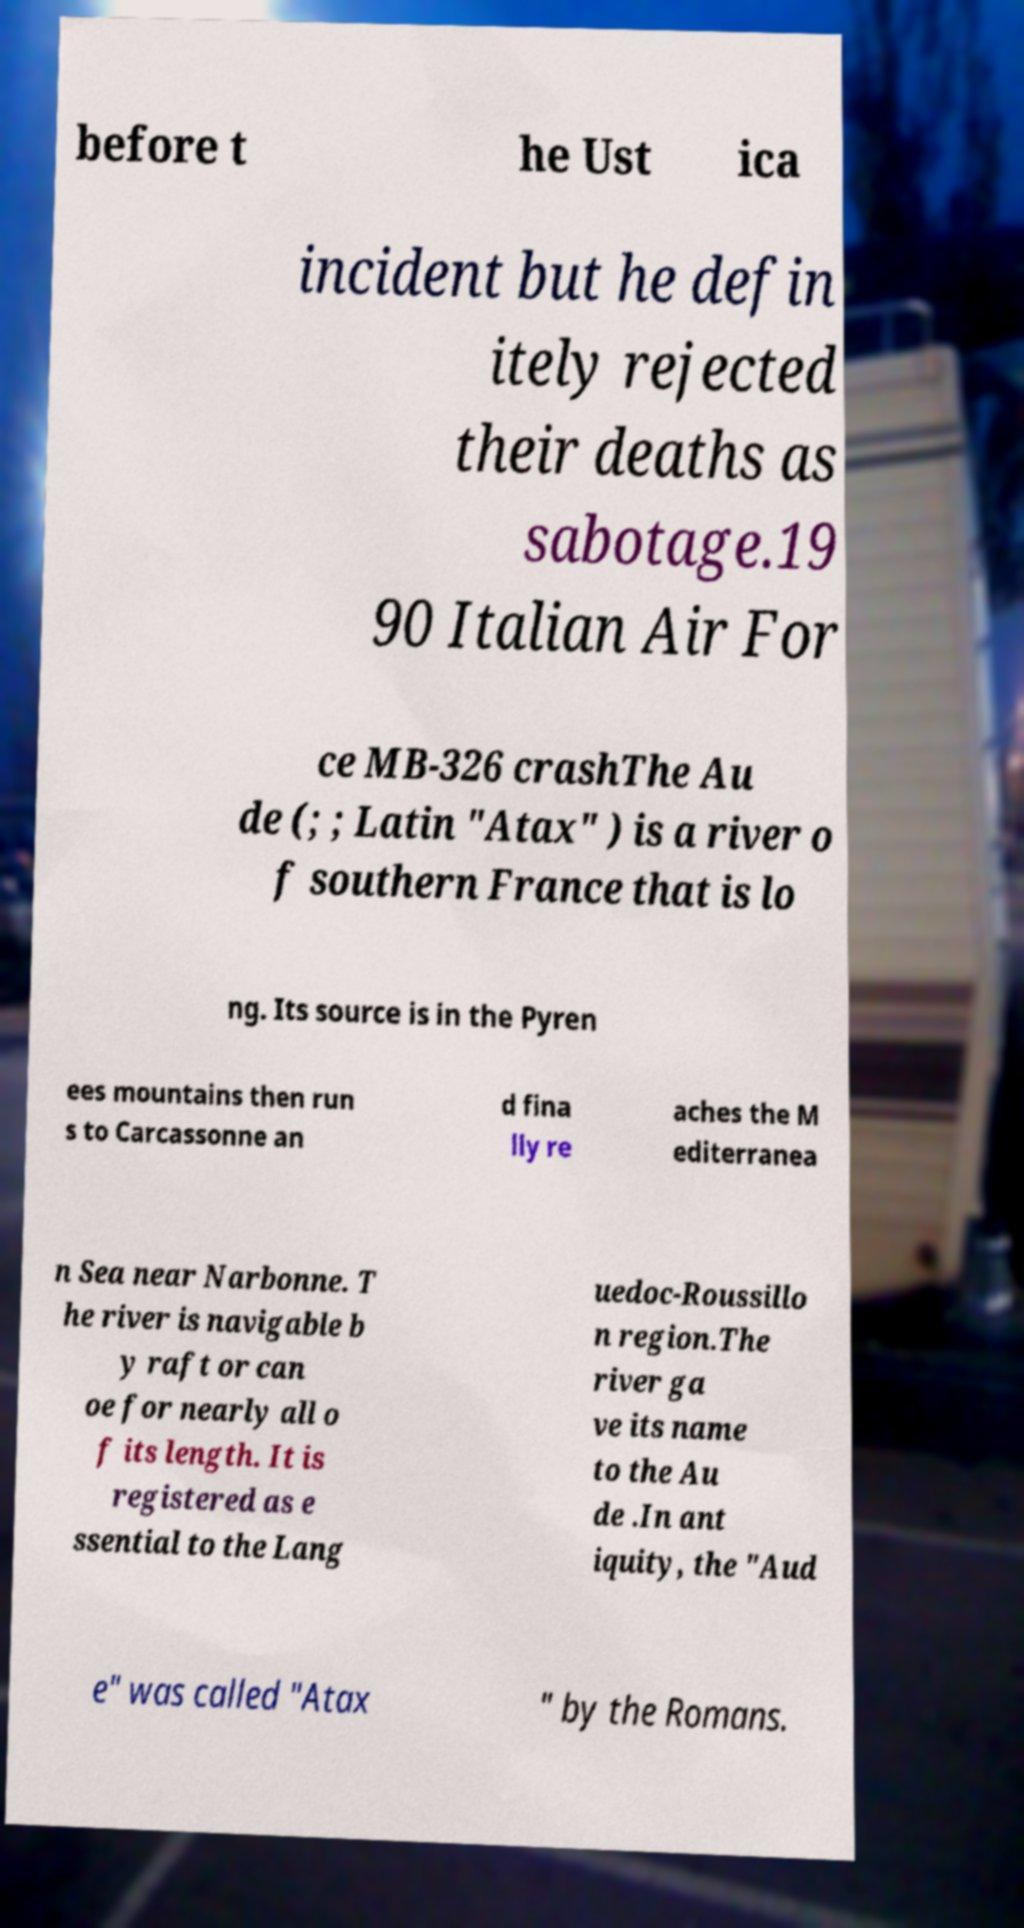Please identify and transcribe the text found in this image. before t he Ust ica incident but he defin itely rejected their deaths as sabotage.19 90 Italian Air For ce MB-326 crashThe Au de (; ; Latin "Atax" ) is a river o f southern France that is lo ng. Its source is in the Pyren ees mountains then run s to Carcassonne an d fina lly re aches the M editerranea n Sea near Narbonne. T he river is navigable b y raft or can oe for nearly all o f its length. It is registered as e ssential to the Lang uedoc-Roussillo n region.The river ga ve its name to the Au de .In ant iquity, the "Aud e" was called "Atax " by the Romans. 